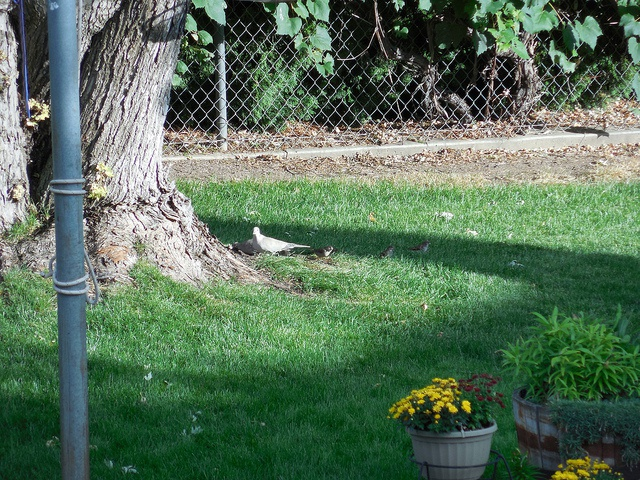Describe the objects in this image and their specific colors. I can see potted plant in darkgray, black, darkgreen, and teal tones, potted plant in darkgray, black, gray, darkgreen, and teal tones, potted plant in darkgray, black, and olive tones, bird in darkgray, white, gray, and lightgray tones, and bird in darkgray, black, gray, and ivory tones in this image. 